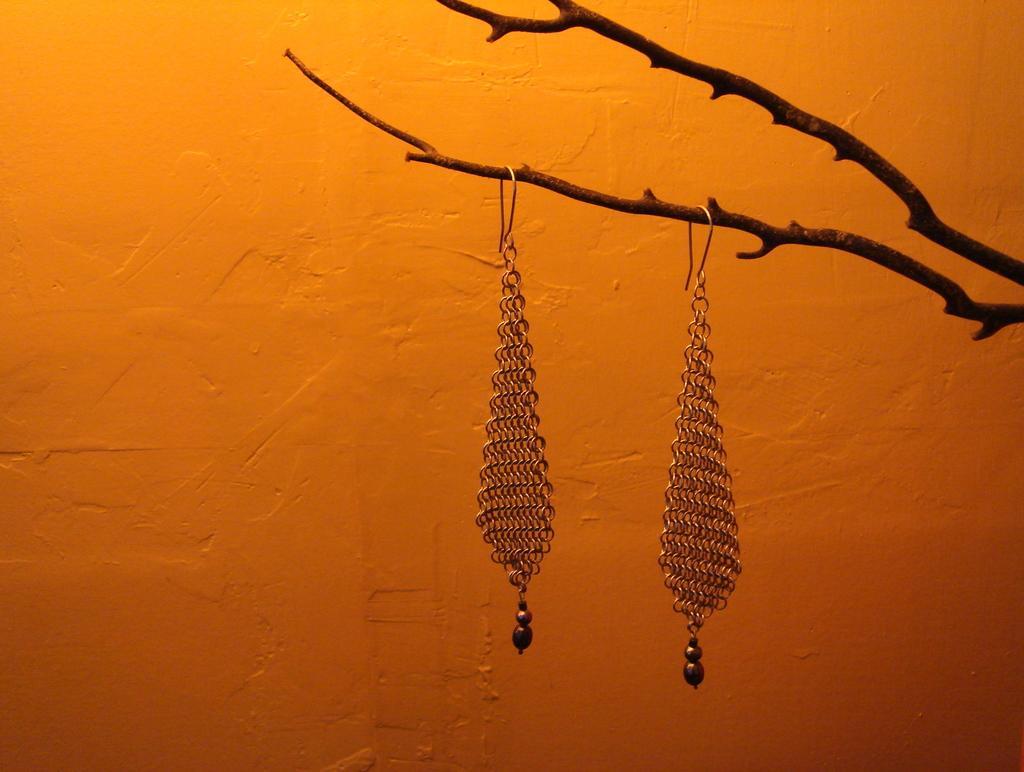In one or two sentences, can you explain what this image depicts? In this image we can see earrings on a tree branch. In the background of the image there is wall. 